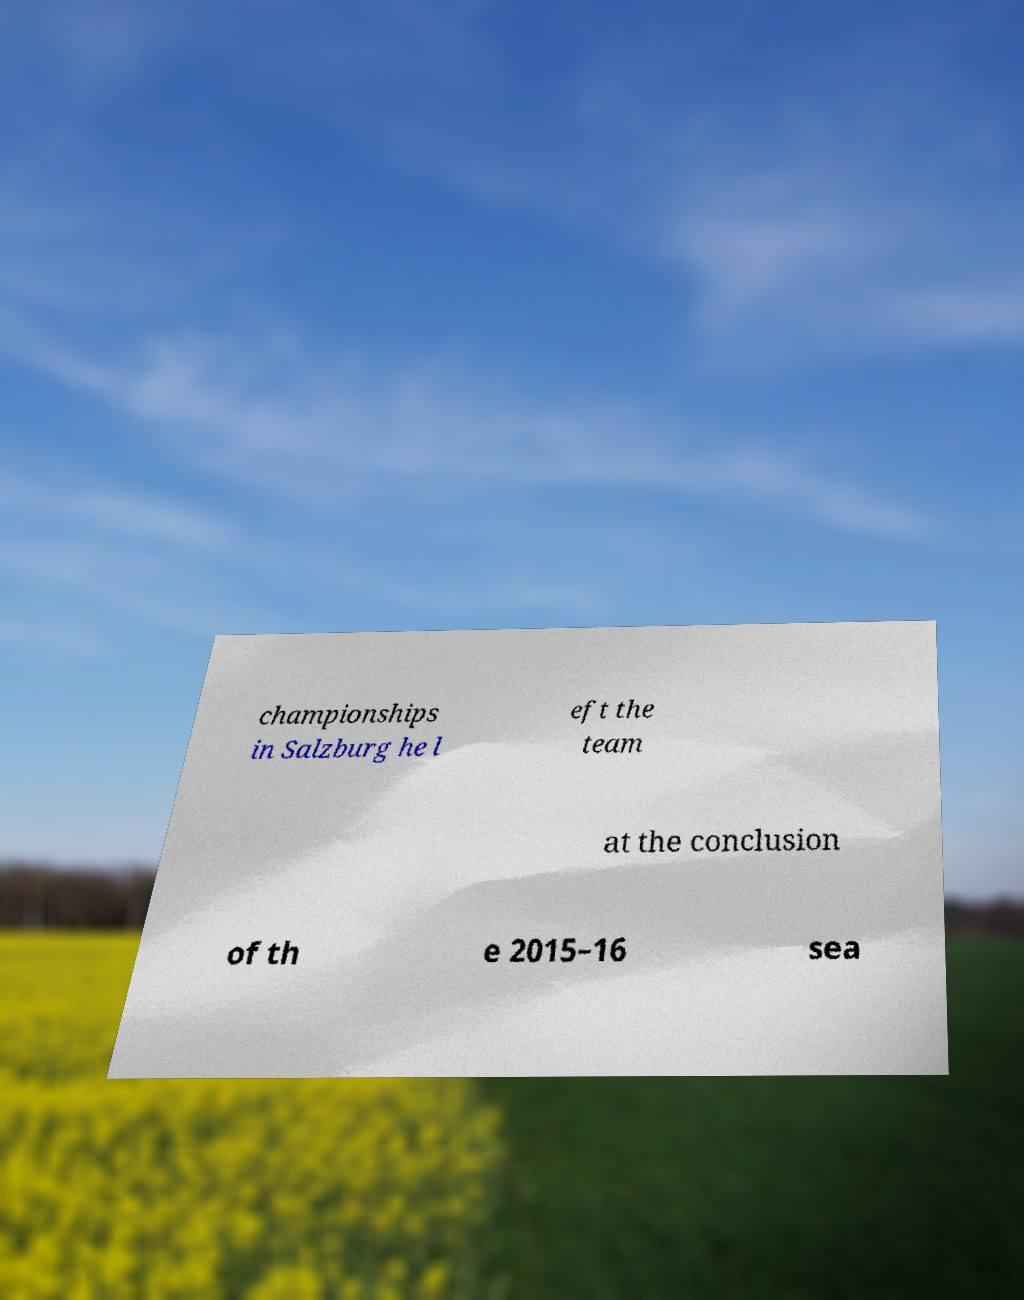Please read and relay the text visible in this image. What does it say? championships in Salzburg he l eft the team at the conclusion of th e 2015–16 sea 